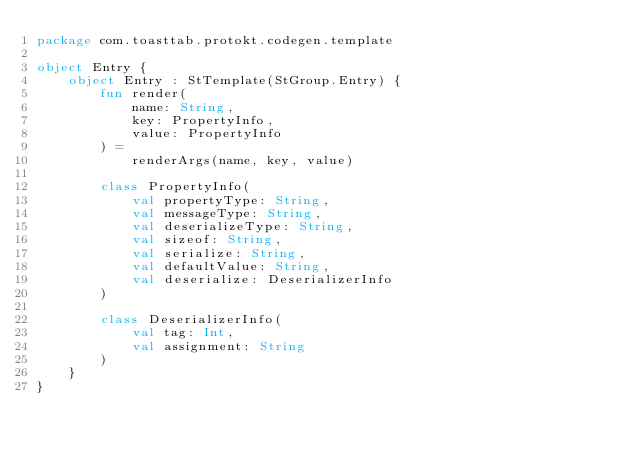<code> <loc_0><loc_0><loc_500><loc_500><_Kotlin_>package com.toasttab.protokt.codegen.template

object Entry {
    object Entry : StTemplate(StGroup.Entry) {
        fun render(
            name: String,
            key: PropertyInfo,
            value: PropertyInfo
        ) =
            renderArgs(name, key, value)

        class PropertyInfo(
            val propertyType: String,
            val messageType: String,
            val deserializeType: String,
            val sizeof: String,
            val serialize: String,
            val defaultValue: String,
            val deserialize: DeserializerInfo
        )

        class DeserializerInfo(
            val tag: Int,
            val assignment: String
        )
    }
}
</code> 